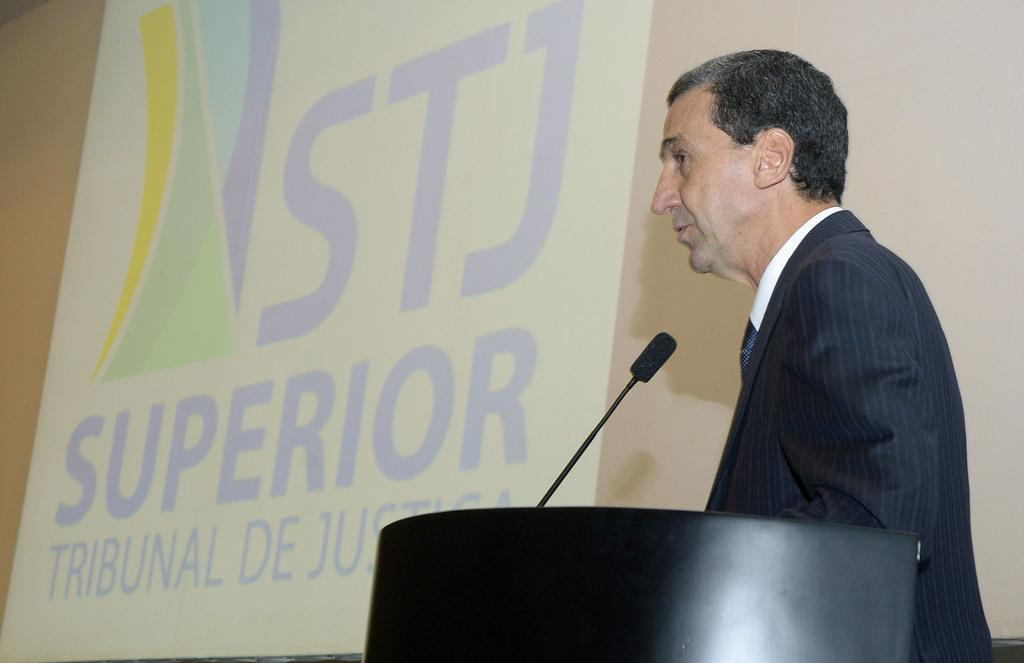What is the man in the image doing? The man is standing near a podium. What object is present for the man to use for speaking? There is a microphone in the image. What can be seen on the screen in the image? There is a display on the screen in the image. What type of hammer is the man holding in the image? There is no hammer present in the image; the man is standing near a podium with a microphone and a screen with a display. 